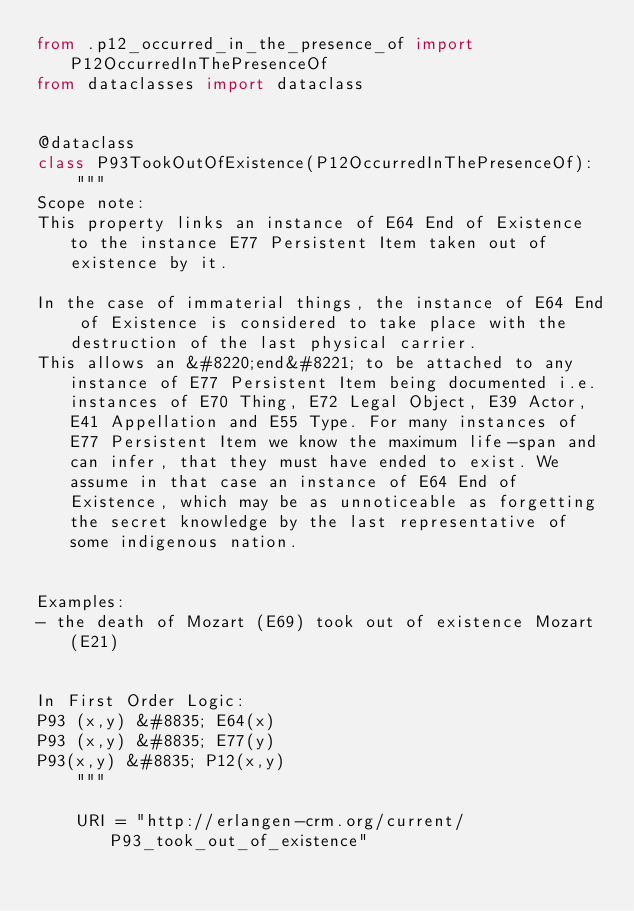Convert code to text. <code><loc_0><loc_0><loc_500><loc_500><_Python_>from .p12_occurred_in_the_presence_of import P12OccurredInThePresenceOf
from dataclasses import dataclass


@dataclass
class P93TookOutOfExistence(P12OccurredInThePresenceOf):
    """
Scope note:
This property links an instance of E64 End of Existence to the instance E77 Persistent Item taken out of existence by it.

In the case of immaterial things, the instance of E64 End of Existence is considered to take place with the destruction of the last physical carrier.
This allows an &#8220;end&#8221; to be attached to any instance of E77 Persistent Item being documented i.e. instances of E70 Thing, E72 Legal Object, E39 Actor, E41 Appellation and E55 Type. For many instances of E77 Persistent Item we know the maximum life-span and can infer, that they must have ended to exist. We assume in that case an instance of E64 End of Existence, which may be as unnoticeable as forgetting the secret knowledge by the last representative of some indigenous nation.


Examples:
- the death of Mozart (E69) took out of existence Mozart (E21)


In First Order Logic:
P93 (x,y) &#8835; E64(x)
P93 (x,y) &#8835; E77(y)
P93(x,y) &#8835; P12(x,y)
    """

    URI = "http://erlangen-crm.org/current/P93_took_out_of_existence"
</code> 